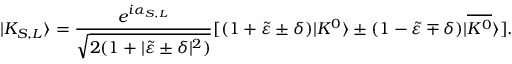<formula> <loc_0><loc_0><loc_500><loc_500>| K _ { S , L } \rangle = \frac { e ^ { i \alpha _ { S , L } } } { \sqrt { 2 ( 1 + | \tilde { \varepsilon } \pm \delta | ^ { 2 } ) } } [ ( 1 + \tilde { \varepsilon } \pm \delta ) | K ^ { 0 } \rangle \pm ( 1 - \tilde { \varepsilon } \mp \delta ) | \overline { { { K ^ { 0 } } } } \rangle ] .</formula> 